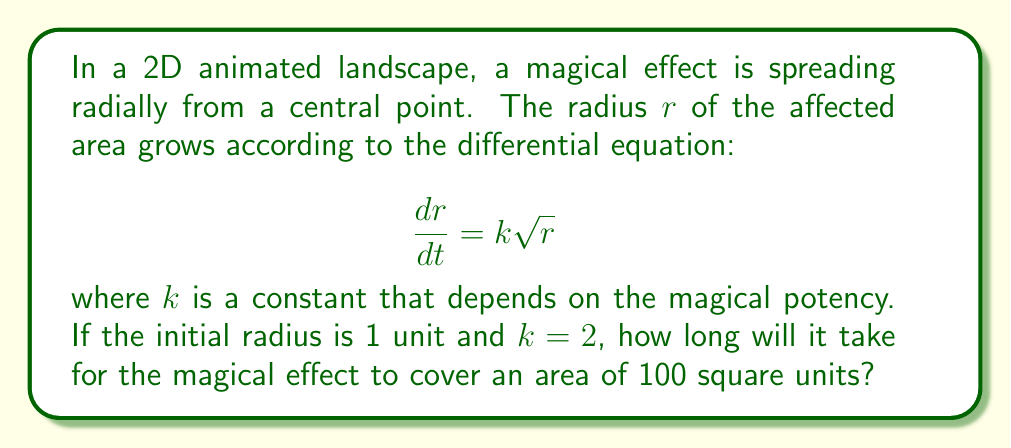Teach me how to tackle this problem. Let's approach this step-by-step:

1) First, we need to solve the differential equation. We can separate variables:

   $$\frac{dr}{\sqrt{r}} = k dt$$

2) Integrating both sides:

   $$\int \frac{dr}{\sqrt{r}} = \int k dt$$
   
   $$2\sqrt{r} = kt + C$$

3) We're given that the initial radius is 1 unit. Let's use this to find C:

   When $t = 0$, $r = 1$
   
   $2\sqrt{1} = k(0) + C$
   
   $2 = C$

4) So our solution is:

   $$2\sqrt{r} = kt + 2$$
   
   $$\sqrt{r} = \frac{kt}{2} + 1$$
   
   $$r = (\frac{kt}{2} + 1)^2$$

5) We're told that $k = 2$, so:

   $$r = (t + 1)^2$$

6) Now, we need to find when the area is 100 square units. The area of a circle is $\pi r^2$, so:

   $$\pi r^2 = 100$$
   
   $$r^2 = \frac{100}{\pi}$$
   
   $$r = 10/\sqrt{\pi}$$

7) Now we can solve for t:

   $$10/\sqrt{\pi} = (t + 1)^2$$
   
   $$\sqrt{10/\sqrt{\pi}} = t + 1$$
   
   $$\sqrt{10/\sqrt{\pi}} - 1 = t$$

8) Simplify:

   $$t = \sqrt{10/\sqrt{\pi}} - 1 \approx 2.3224$$
Answer: It will take approximately 2.3224 time units for the magical effect to cover an area of 100 square units. 